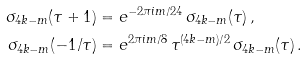<formula> <loc_0><loc_0><loc_500><loc_500>\sigma _ { 4 k - m } ( \tau + 1 ) & = e ^ { - 2 \pi i m / 2 4 } \, \sigma _ { 4 k - m } ( \tau ) \, , \\ \sigma _ { 4 k - m } ( - 1 / \tau ) & = e ^ { 2 \pi i m / 8 } \, \tau ^ { ( 4 k - m ) / 2 } \, \sigma _ { 4 k - m } ( \tau ) \, .</formula> 